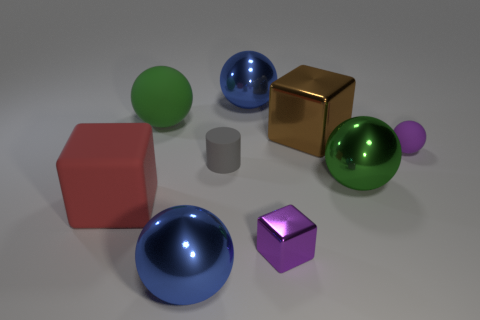Which objects in the image are most similar in shape, and what differentiates their appearance? The two spherical objects share the closest resemblance in shape, as they both have a continuous, round surface. However, one sphere showcases a metallic finish that gleams with light and color reflections, while the other has a non-reflective, matte exterior that scatters light evenly, creating distinct visual experiences despite their similar shapes. 